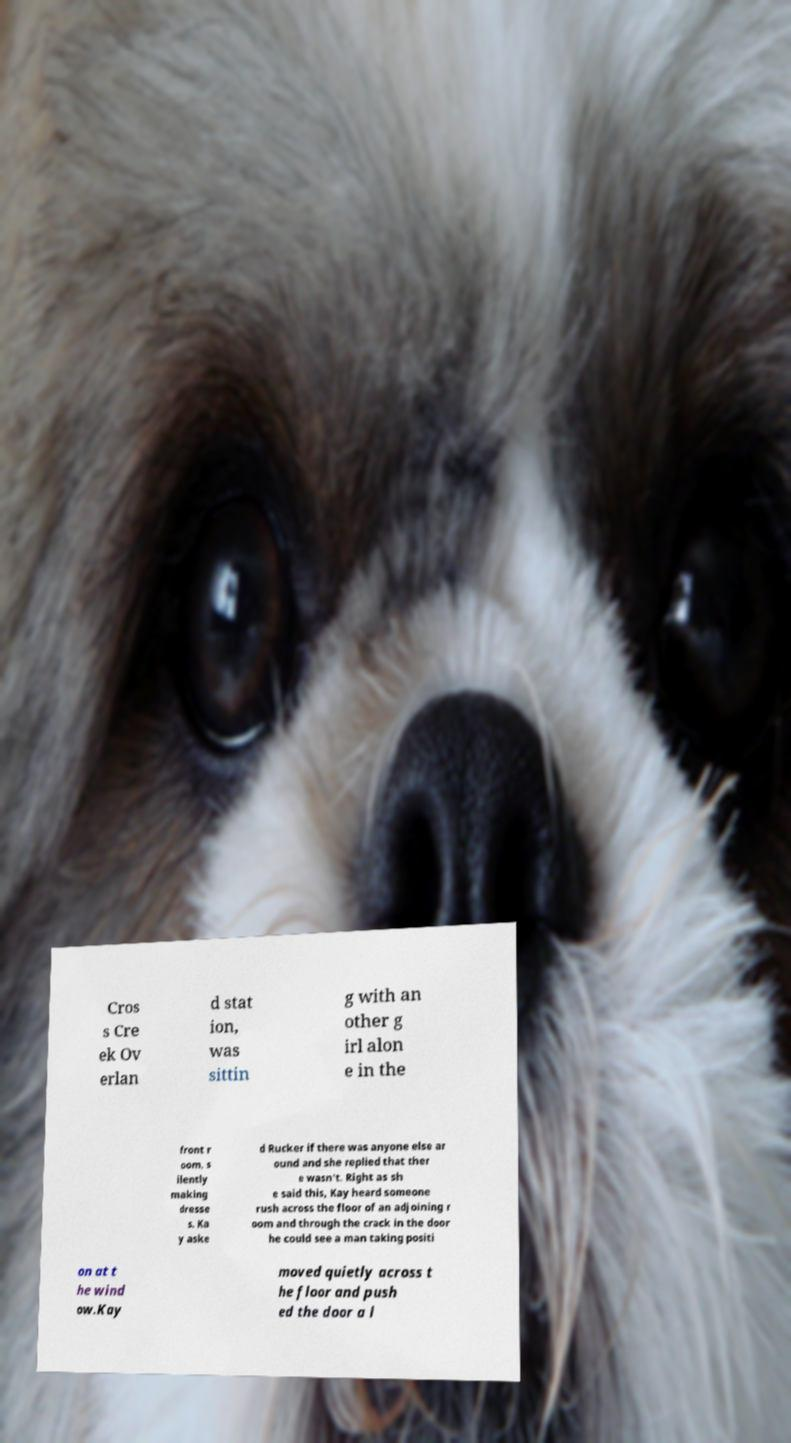Could you assist in decoding the text presented in this image and type it out clearly? Cros s Cre ek Ov erlan d stat ion, was sittin g with an other g irl alon e in the front r oom, s ilently making dresse s. Ka y aske d Rucker if there was anyone else ar ound and she replied that ther e wasn't. Right as sh e said this, Kay heard someone rush across the floor of an adjoining r oom and through the crack in the door he could see a man taking positi on at t he wind ow.Kay moved quietly across t he floor and push ed the door a l 